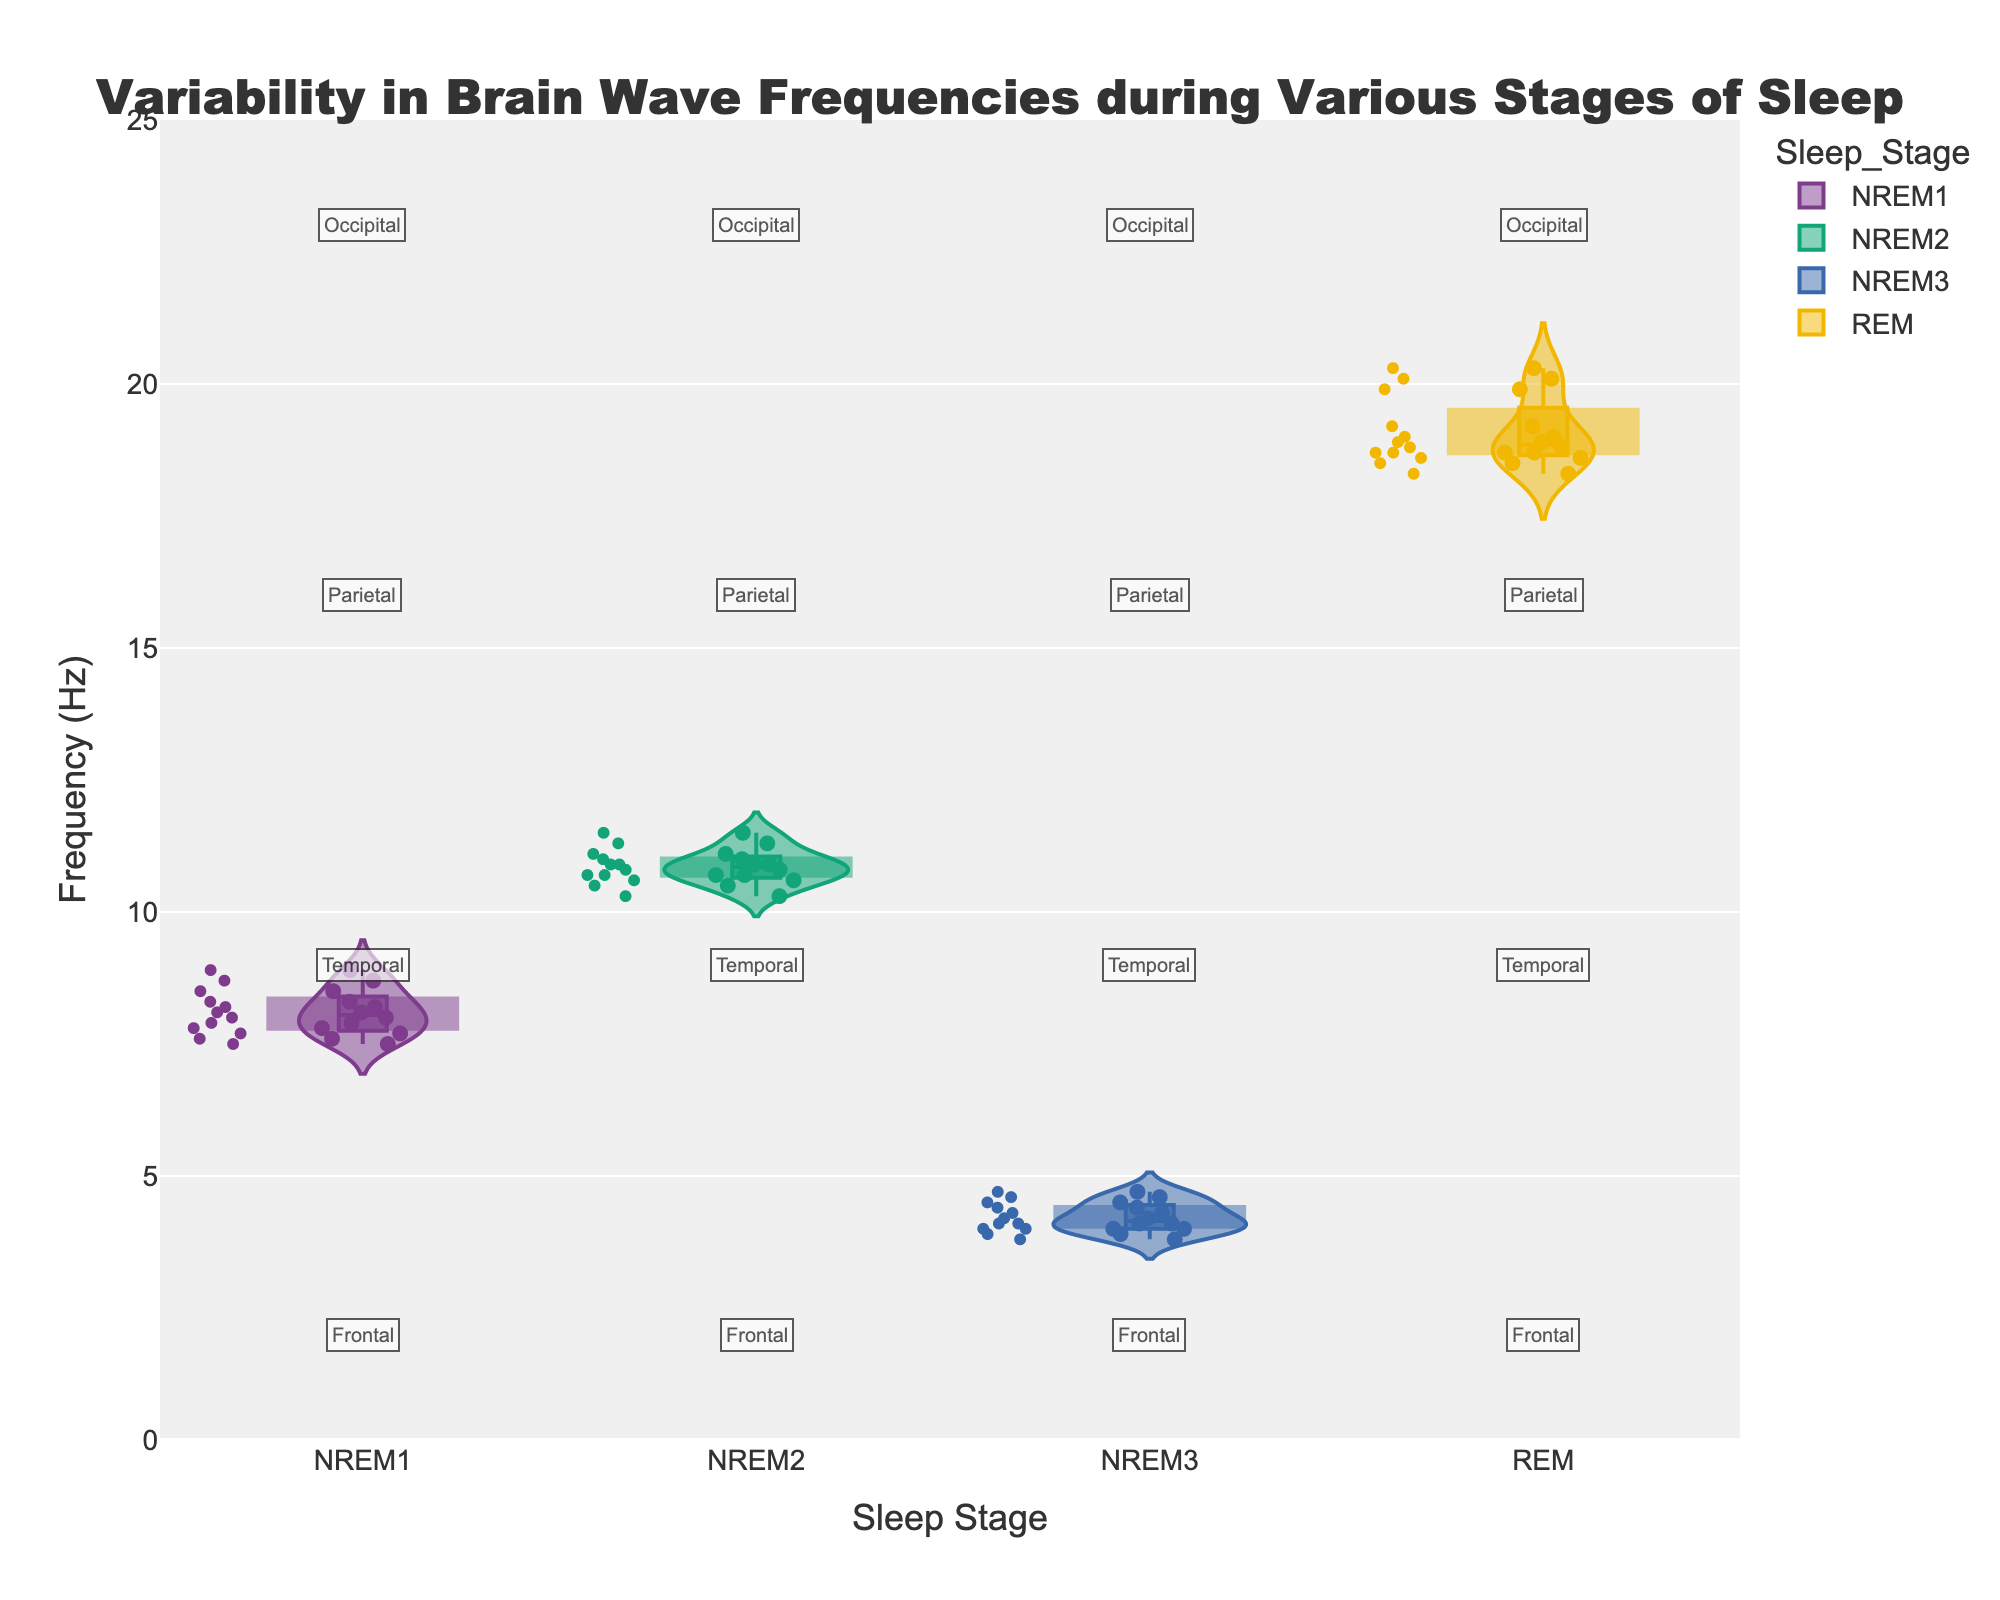what is the title of the figure? The title of any figure is usually prominently displayed at the top, often in a larger font size and boldface text. This figure's title is positioned centrally, making it easily noticeable.
Answer: Variability in Brain Wave Frequencies during Various Stages of Sleep What are the axes labels in the plot? The axes labels are generally found directly beside the respective axes. The x-axis specifically talks about the categorization of data and the y-axis deals with the measured variable.
Answer: Sleep Stage and Frequency (Hz) How many sleep stages are represented in the plot? To determine the number of sleep stages, count the different categories labeled along the x-axis. Each unique category represents a different sleep stage.
Answer: 4 Which sleep stage shows the highest range in brain wave frequencies? A violin plot visually displays the distribution where the spread of values is evident through the width of the plot along the y-axis. The stage with the widest spread along the y-axis signifies the highest range in frequencies.
Answer: REM In NREM2, which brain region has the highest brain wave frequency recorded? Observe the jittered points within the NREM2 violin plot to find the highest point on the y-axis and then identify its corresponding brain region from annotations.
Answer: Frontal What can you infer about the variability in brain wave frequencies during NREM3 as compared to others? By visually comparing the spreads and widths of the violin plots of each sleep stage, discern if NREM3 has a wider or narrower spread, indicating more or less variability, respectively.
Answer: NREM3 has less variability What appears to be the central tendency (median) of brain wave frequencies during REM? The inner box plot within the violin chart provides the median, usually represented by a horizontal line within the box. Locate this in the REM section.
Answer: About 19 Hz Between NREM1 and NREM2, which has brain wave frequencies that generally appear higher? Compare the position of the jittered points and the general height of the violins to see which stage has its points located higher on the y-axis.
Answer: NREM2 Which brain region is associated with the highest recorded frequency in REM? By inspecting the jittered points for the highest value in the REM section, identify the corresponding brain region from the annotations near that point.
Answer: Frontal How does the median frequency in NREM3 compare with that in NREM1? Locate and compare the median lines within the box plots of the NREM3 and NREM1 violin sections to see which is higher or lower.
Answer: NREM1 median is higher 